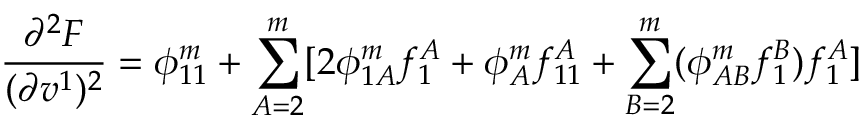Convert formula to latex. <formula><loc_0><loc_0><loc_500><loc_500>\frac { \partial ^ { 2 } F } { ( \partial v ^ { 1 } ) ^ { 2 } } = \phi _ { 1 1 } ^ { m } + \sum _ { A = 2 } ^ { m } [ 2 \phi _ { 1 A } ^ { m } f _ { 1 } ^ { A } + \phi _ { A } ^ { m } f _ { 1 1 } ^ { A } + \sum _ { B = 2 } ^ { m } ( \phi _ { A B } ^ { m } f _ { 1 } ^ { B } ) f _ { 1 } ^ { A } ]</formula> 